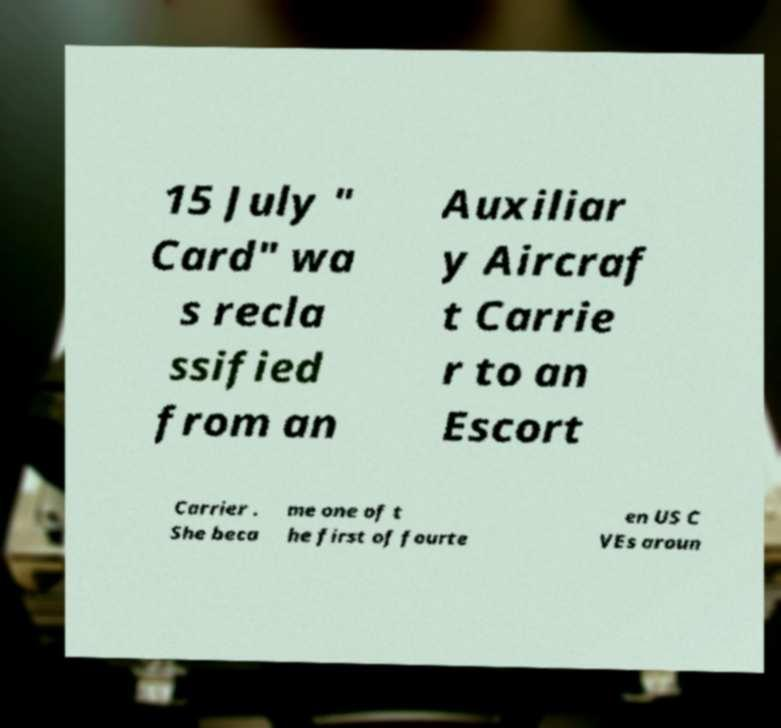Please identify and transcribe the text found in this image. 15 July " Card" wa s recla ssified from an Auxiliar y Aircraf t Carrie r to an Escort Carrier . She beca me one of t he first of fourte en US C VEs aroun 